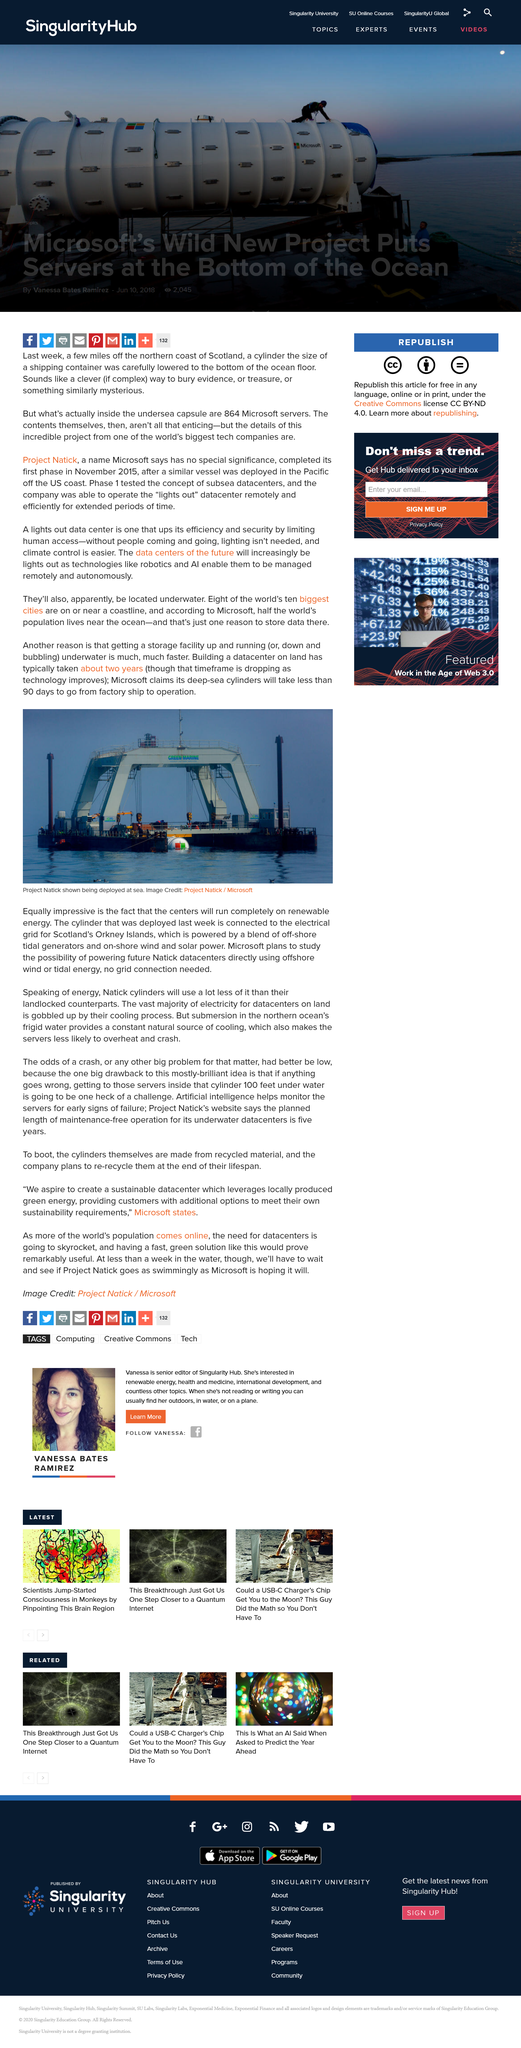Highlight a few significant elements in this photo. According to Microsoft, it takes 90 days for their deep-sea cylinders to be transported from the factory ship to operation. The photograph depicts Project Natick, a sea deployment, being conducted. Building a datacenter on land typically takes approximately two years. 